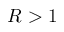Convert formula to latex. <formula><loc_0><loc_0><loc_500><loc_500>R > 1</formula> 